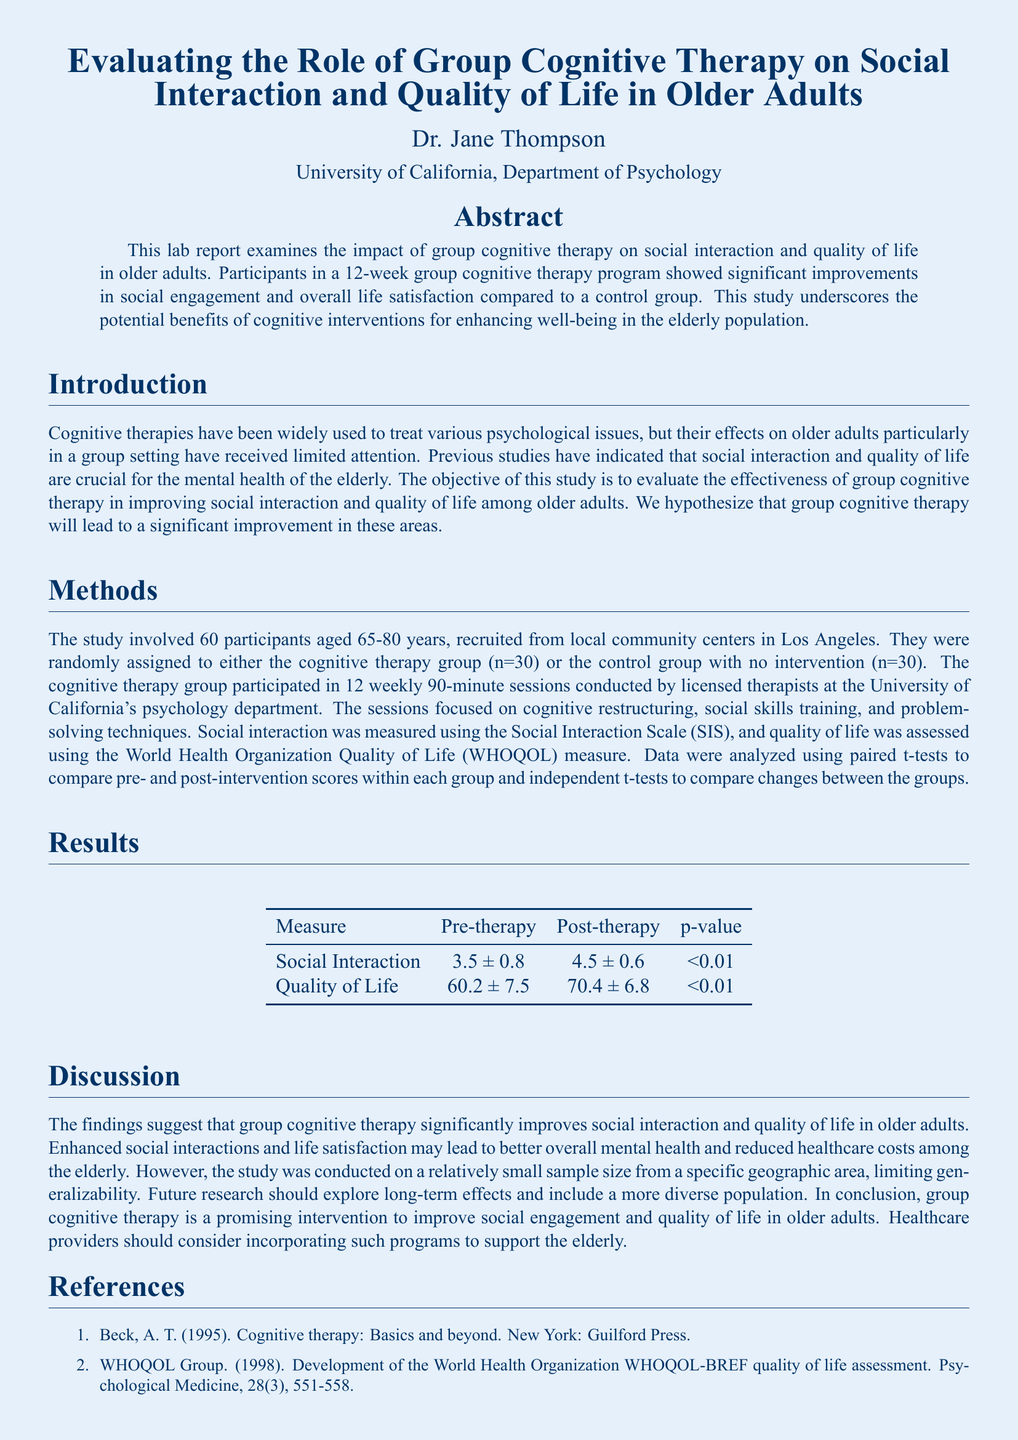What was the age range of participants in the study? The age range of participants was specified as between 65 and 80 years old.
Answer: 65-80 years How many participants were in the cognitive therapy group? The document states that there were 30 participants in the cognitive therapy group.
Answer: 30 What was the purpose of the group cognitive therapy sessions? The purpose of the sessions included cognitive restructuring, social skills training, and problem-solving techniques.
Answer: Cognitive restructuring, social skills training, problem-solving techniques What was the pre-therapy score for social interaction? The document specifies the pre-therapy score for social interaction as 3.5 ± 0.8.
Answer: 3.5 ± 0.8 What statistical method was used to compare changes between the groups? The document mentions using independent t-tests to compare changes between the groups.
Answer: Independent t-tests What was the post-therapy quality of life score? The post-therapy quality of life score mentioned in the document is 70.4 ± 6.8.
Answer: 70.4 ± 6.8 What is the main conclusion drawn from the study? The conclusion indicates that group cognitive therapy is a promising intervention for improving social engagement and quality of life in older adults.
Answer: Promising intervention How long did the cognitive therapy program last? The duration of the cognitive therapy program was specified as 12 weeks.
Answer: 12 weeks 